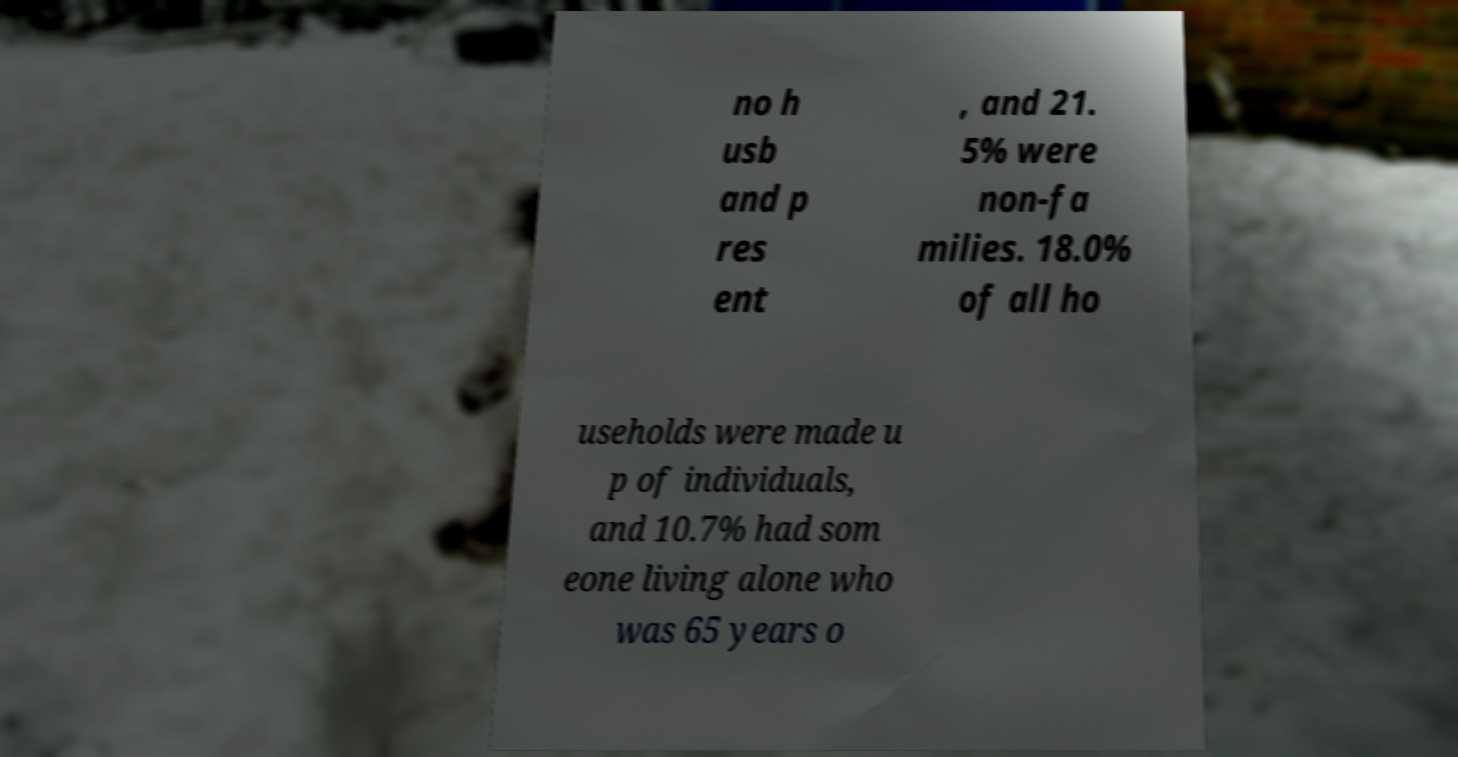Can you accurately transcribe the text from the provided image for me? no h usb and p res ent , and 21. 5% were non-fa milies. 18.0% of all ho useholds were made u p of individuals, and 10.7% had som eone living alone who was 65 years o 